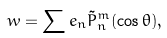Convert formula to latex. <formula><loc_0><loc_0><loc_500><loc_500>w = \sum e _ { n } \tilde { P } ^ { m } _ { n } ( \cos \theta ) ,</formula> 